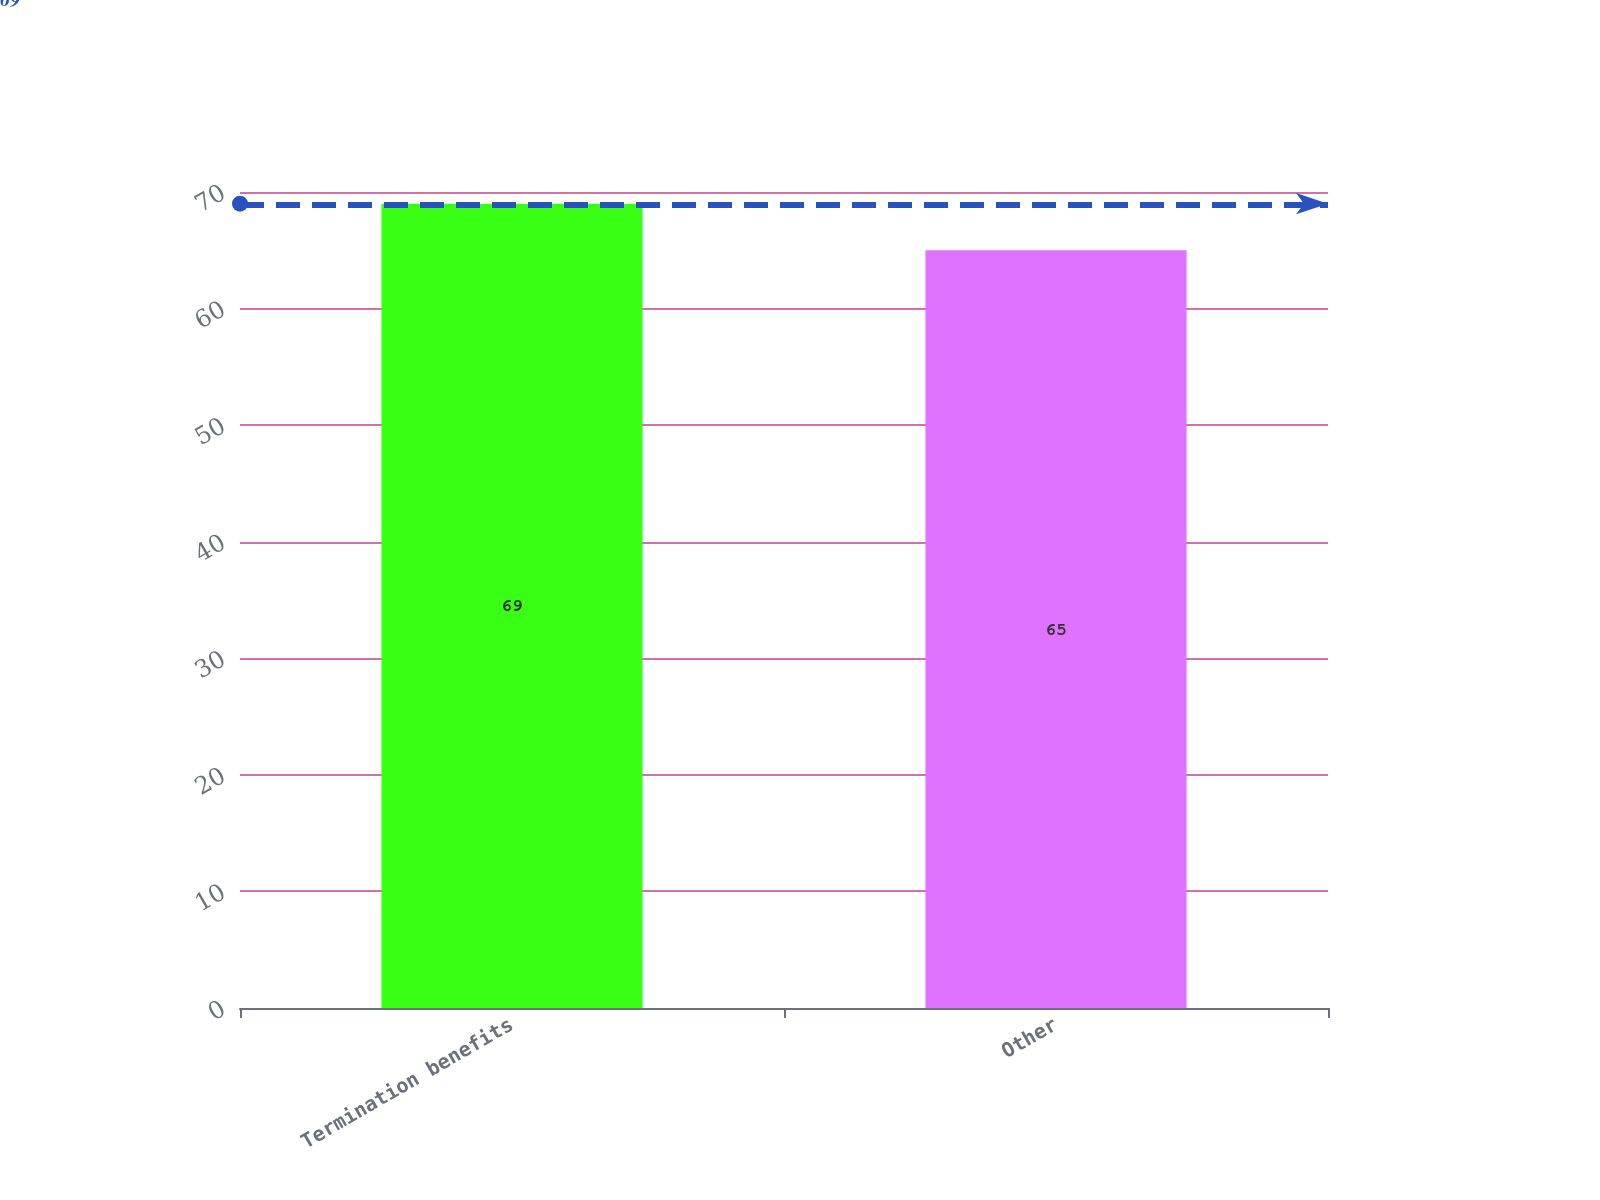Convert chart to OTSL. <chart><loc_0><loc_0><loc_500><loc_500><bar_chart><fcel>Termination benefits<fcel>Other<nl><fcel>69<fcel>65<nl></chart> 